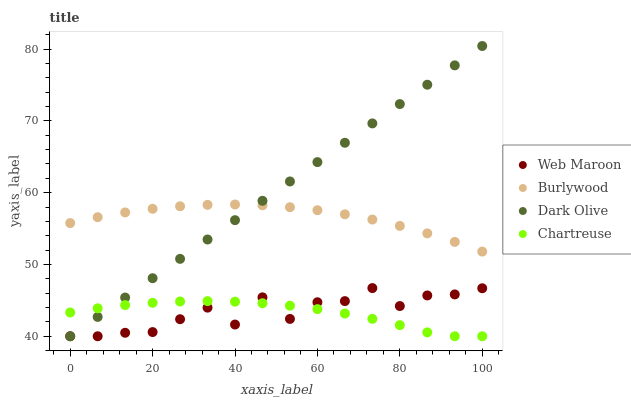Does Chartreuse have the minimum area under the curve?
Answer yes or no. Yes. Does Dark Olive have the maximum area under the curve?
Answer yes or no. Yes. Does Dark Olive have the minimum area under the curve?
Answer yes or no. No. Does Chartreuse have the maximum area under the curve?
Answer yes or no. No. Is Dark Olive the smoothest?
Answer yes or no. Yes. Is Web Maroon the roughest?
Answer yes or no. Yes. Is Chartreuse the smoothest?
Answer yes or no. No. Is Chartreuse the roughest?
Answer yes or no. No. Does Chartreuse have the lowest value?
Answer yes or no. Yes. Does Dark Olive have the highest value?
Answer yes or no. Yes. Does Chartreuse have the highest value?
Answer yes or no. No. Is Web Maroon less than Burlywood?
Answer yes or no. Yes. Is Burlywood greater than Chartreuse?
Answer yes or no. Yes. Does Dark Olive intersect Burlywood?
Answer yes or no. Yes. Is Dark Olive less than Burlywood?
Answer yes or no. No. Is Dark Olive greater than Burlywood?
Answer yes or no. No. Does Web Maroon intersect Burlywood?
Answer yes or no. No. 